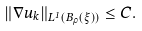Convert formula to latex. <formula><loc_0><loc_0><loc_500><loc_500>\| \nabla u _ { k } \| _ { L ^ { 1 } ( B _ { \rho } ( \xi ) ) } \leq C .</formula> 